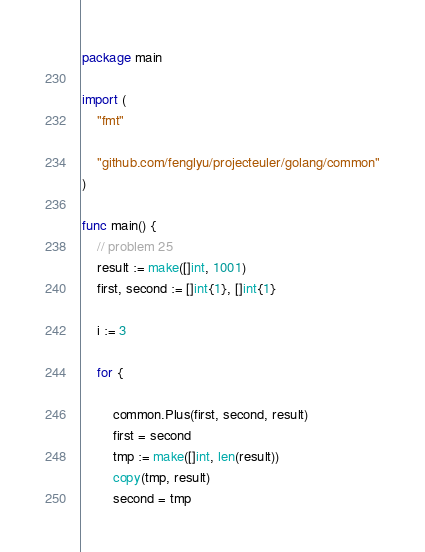<code> <loc_0><loc_0><loc_500><loc_500><_Go_>package main

import (
	"fmt"

	"github.com/fenglyu/projecteuler/golang/common"
)

func main() {
	// problem 25
	result := make([]int, 1001)
	first, second := []int{1}, []int{1}

	i := 3

	for {

		common.Plus(first, second, result)
		first = second
		tmp := make([]int, len(result))
		copy(tmp, result)
		second = tmp
</code> 